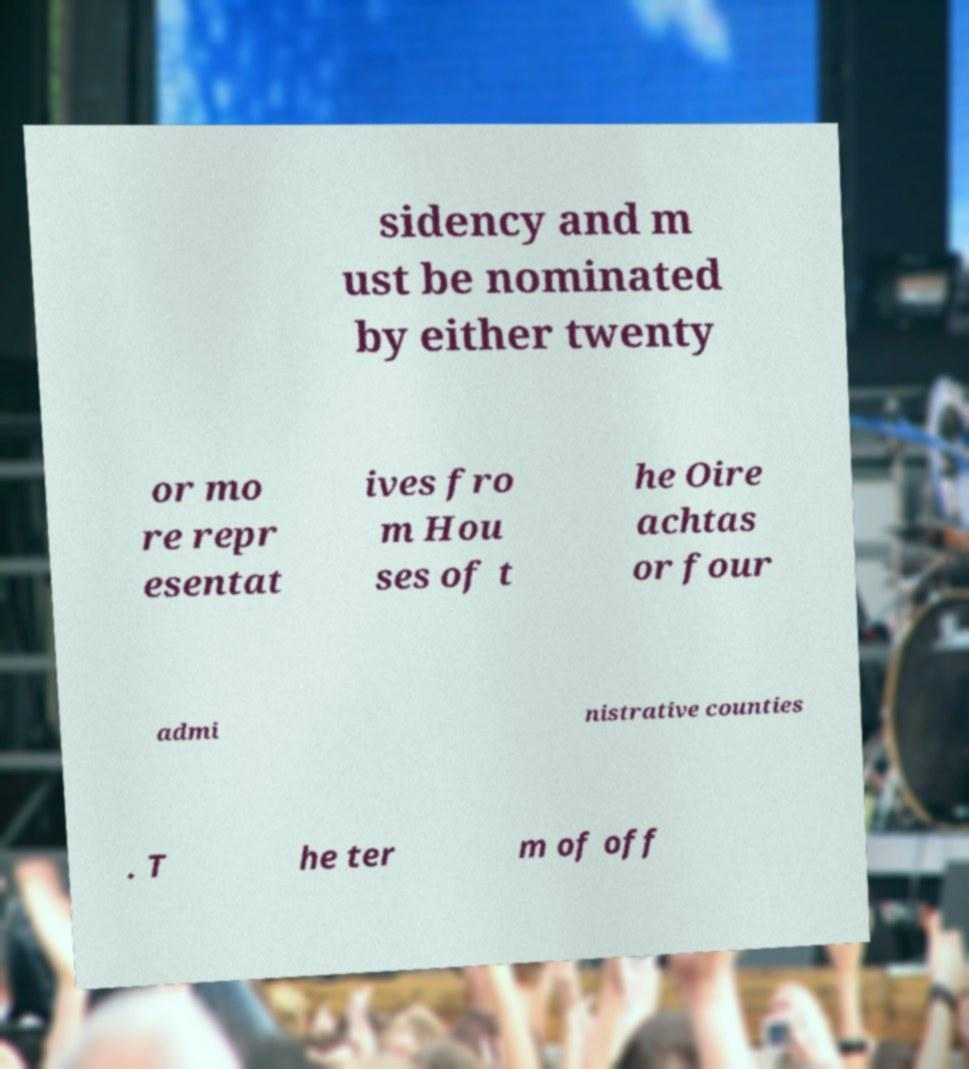Can you read and provide the text displayed in the image?This photo seems to have some interesting text. Can you extract and type it out for me? sidency and m ust be nominated by either twenty or mo re repr esentat ives fro m Hou ses of t he Oire achtas or four admi nistrative counties . T he ter m of off 